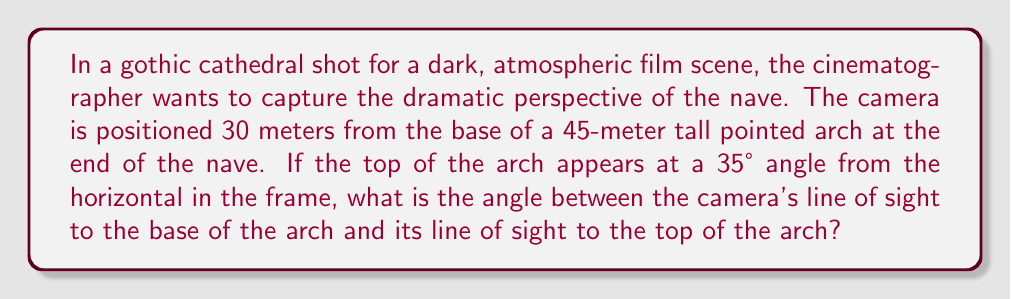What is the answer to this math problem? Let's approach this step-by-step:

1) First, we can visualize this as a right triangle, where:
   - The base is the distance from the camera to the base of the arch (30 m)
   - The height is the height of the arch (45 m)
   - The hypotenuse is the line of sight from the camera to the top of the arch

2) We're given that the angle between the horizontal and the line of sight to the top is 35°. Let's call the angle we're looking for $\theta$.

3) We can find $\theta$ by subtracting the angle to the horizontal from the total angle in the right triangle:

   $$\theta = \tan^{-1}(\frac{45}{30}) - 35°$$

4) Let's calculate the inverse tangent:

   $$\tan^{-1}(\frac{45}{30}) = \tan^{-1}(1.5) \approx 56.31°$$

5) Now we can subtract:

   $$\theta = 56.31° - 35° = 21.31°$$

6) Rounding to the nearest degree:

   $$\theta \approx 21°$$

This angle creates the dramatic upward perspective characteristic of gothic architecture, emphasizing the towering height and spiritual aspiration in the scene.
Answer: $21°$ 